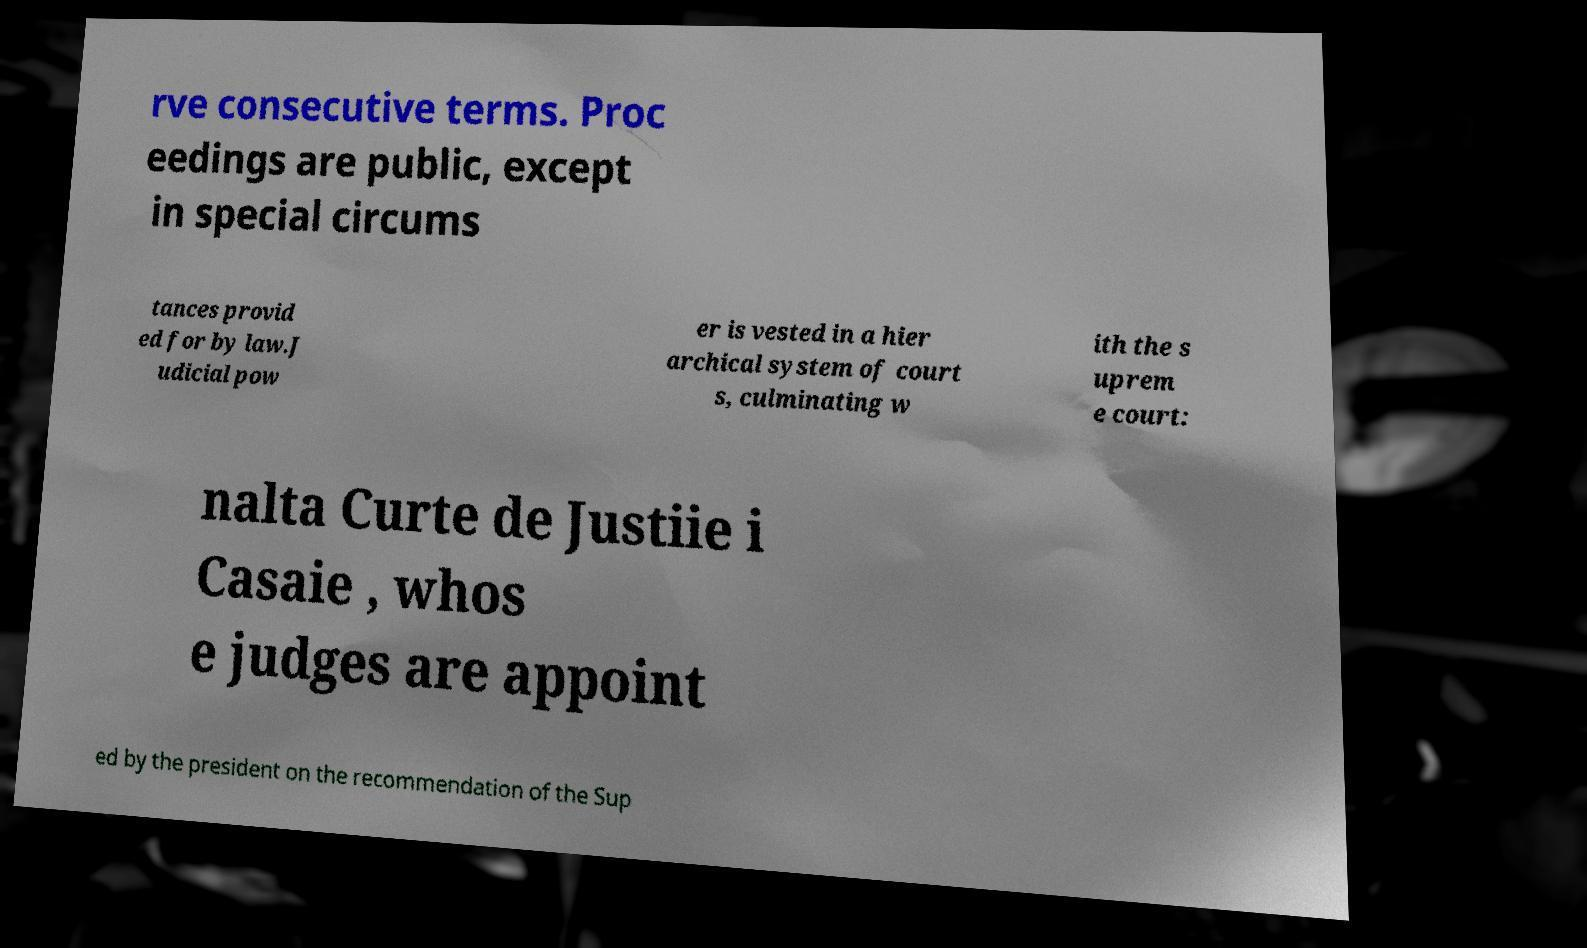Could you extract and type out the text from this image? rve consecutive terms. Proc eedings are public, except in special circums tances provid ed for by law.J udicial pow er is vested in a hier archical system of court s, culminating w ith the s uprem e court: nalta Curte de Justiie i Casaie , whos e judges are appoint ed by the president on the recommendation of the Sup 